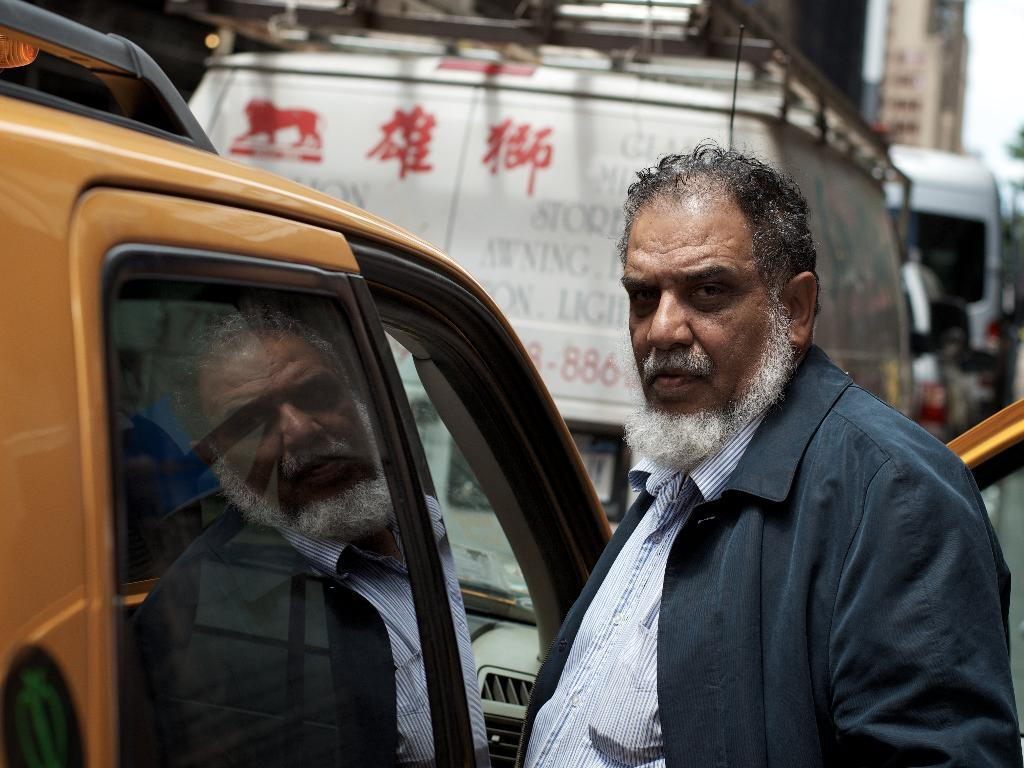What is the main subject of the image? There is a man in the image. What is the man wearing? The man is wearing a black suit. Where is the man positioned in the image? The man is standing in the front of the image. What is the man doing in the image? The man is looking at the camera. What type of vehicle is beside the man? There is a yellow car beside the man. What can be seen in the background of the image? There is a bus visible on the road in the background of the image. What month is it in the image? The month cannot be determined from the image, as there is no information about the time of year. What type of sail can be seen on the man's clothing? There is no sail present on the man's clothing, as he is wearing a black suit. 